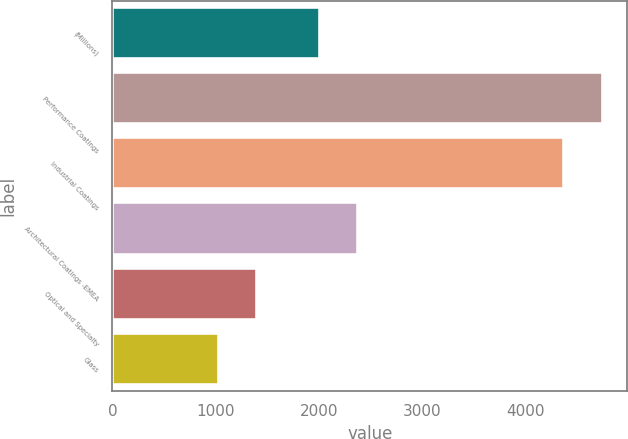<chart> <loc_0><loc_0><loc_500><loc_500><bar_chart><fcel>(Millions)<fcel>Performance Coatings<fcel>Industrial Coatings<fcel>Architectural Coatings -EMEA<fcel>Optical and Specialty<fcel>Glass<nl><fcel>2012<fcel>4752<fcel>4379<fcel>2384<fcel>1404<fcel>1032<nl></chart> 